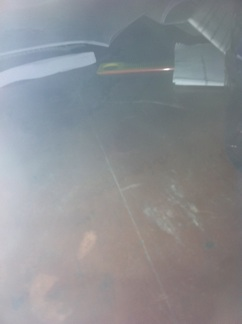Is there a bottle on the table? No, there is no bottle on the table. 